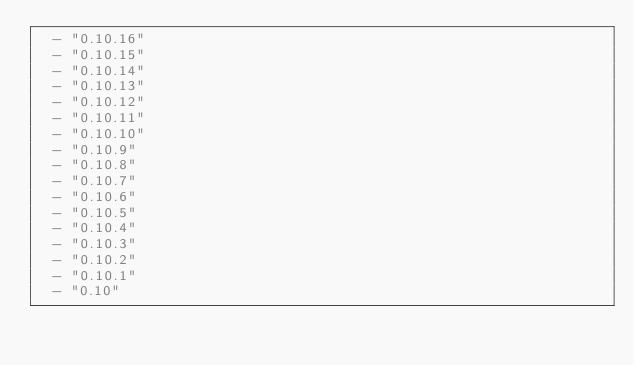Convert code to text. <code><loc_0><loc_0><loc_500><loc_500><_YAML_>  - "0.10.16"
  - "0.10.15"
  - "0.10.14"
  - "0.10.13"
  - "0.10.12"
  - "0.10.11"
  - "0.10.10"
  - "0.10.9"
  - "0.10.8"
  - "0.10.7"
  - "0.10.6"
  - "0.10.5"
  - "0.10.4"
  - "0.10.3"
  - "0.10.2"
  - "0.10.1"
  - "0.10"
</code> 